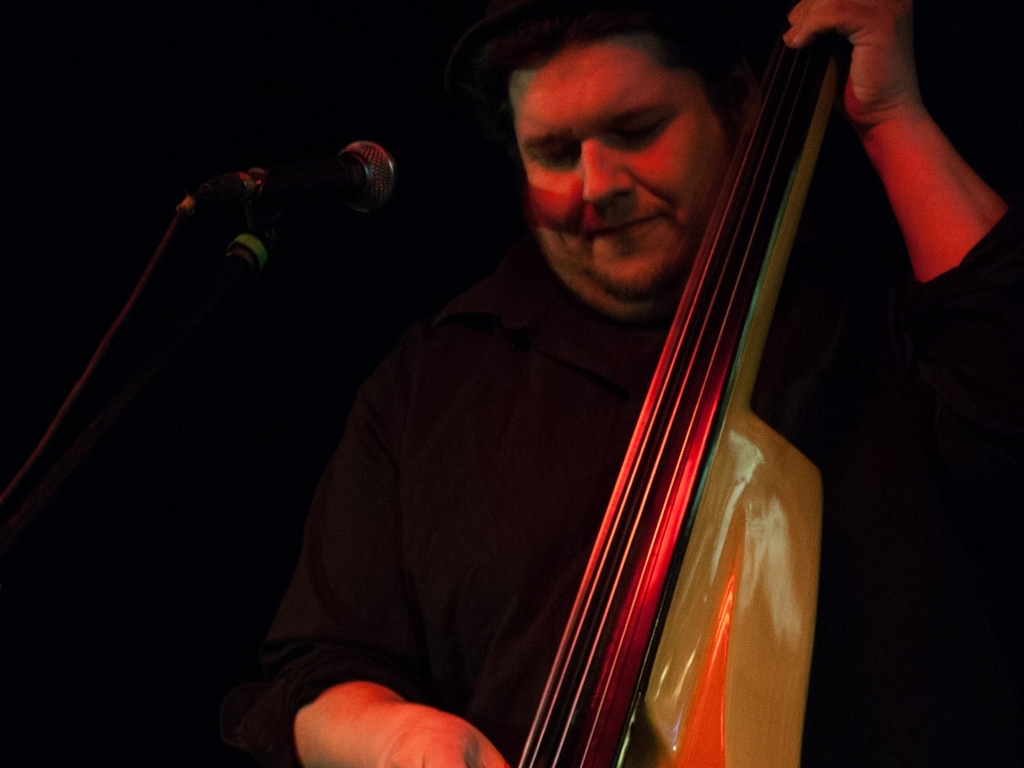Can you describe the atmosphere of the place where this photograph was taken? The photograph seems to capture a low-lit ambiance, typical of a jazz or music club where live performances occur. The warm, subdued lighting suggests an intimate setting where the focus is on the musical experience. 